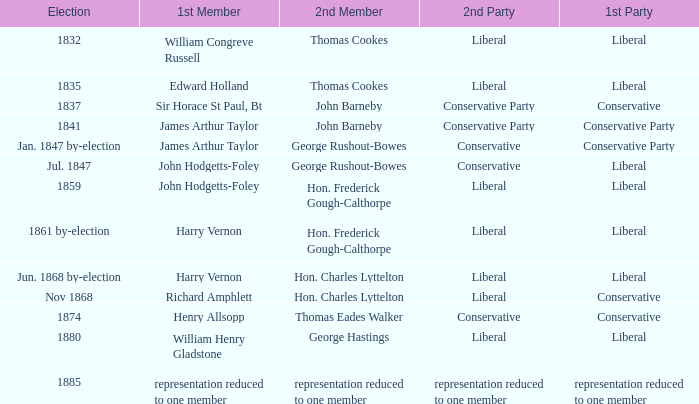If the 1st party is conservative, identify the 2nd party that had john barneby as its 2nd member. Conservative Party. Could you parse the entire table as a dict? {'header': ['Election', '1st Member', '2nd Member', '2nd Party', '1st Party'], 'rows': [['1832', 'William Congreve Russell', 'Thomas Cookes', 'Liberal', 'Liberal'], ['1835', 'Edward Holland', 'Thomas Cookes', 'Liberal', 'Liberal'], ['1837', 'Sir Horace St Paul, Bt', 'John Barneby', 'Conservative Party', 'Conservative'], ['1841', 'James Arthur Taylor', 'John Barneby', 'Conservative Party', 'Conservative Party'], ['Jan. 1847 by-election', 'James Arthur Taylor', 'George Rushout-Bowes', 'Conservative', 'Conservative Party'], ['Jul. 1847', 'John Hodgetts-Foley', 'George Rushout-Bowes', 'Conservative', 'Liberal'], ['1859', 'John Hodgetts-Foley', 'Hon. Frederick Gough-Calthorpe', 'Liberal', 'Liberal'], ['1861 by-election', 'Harry Vernon', 'Hon. Frederick Gough-Calthorpe', 'Liberal', 'Liberal'], ['Jun. 1868 by-election', 'Harry Vernon', 'Hon. Charles Lyttelton', 'Liberal', 'Liberal'], ['Nov 1868', 'Richard Amphlett', 'Hon. Charles Lyttelton', 'Liberal', 'Conservative'], ['1874', 'Henry Allsopp', 'Thomas Eades Walker', 'Conservative', 'Conservative'], ['1880', 'William Henry Gladstone', 'George Hastings', 'Liberal', 'Liberal'], ['1885', 'representation reduced to one member', 'representation reduced to one member', 'representation reduced to one member', 'representation reduced to one member']]} 